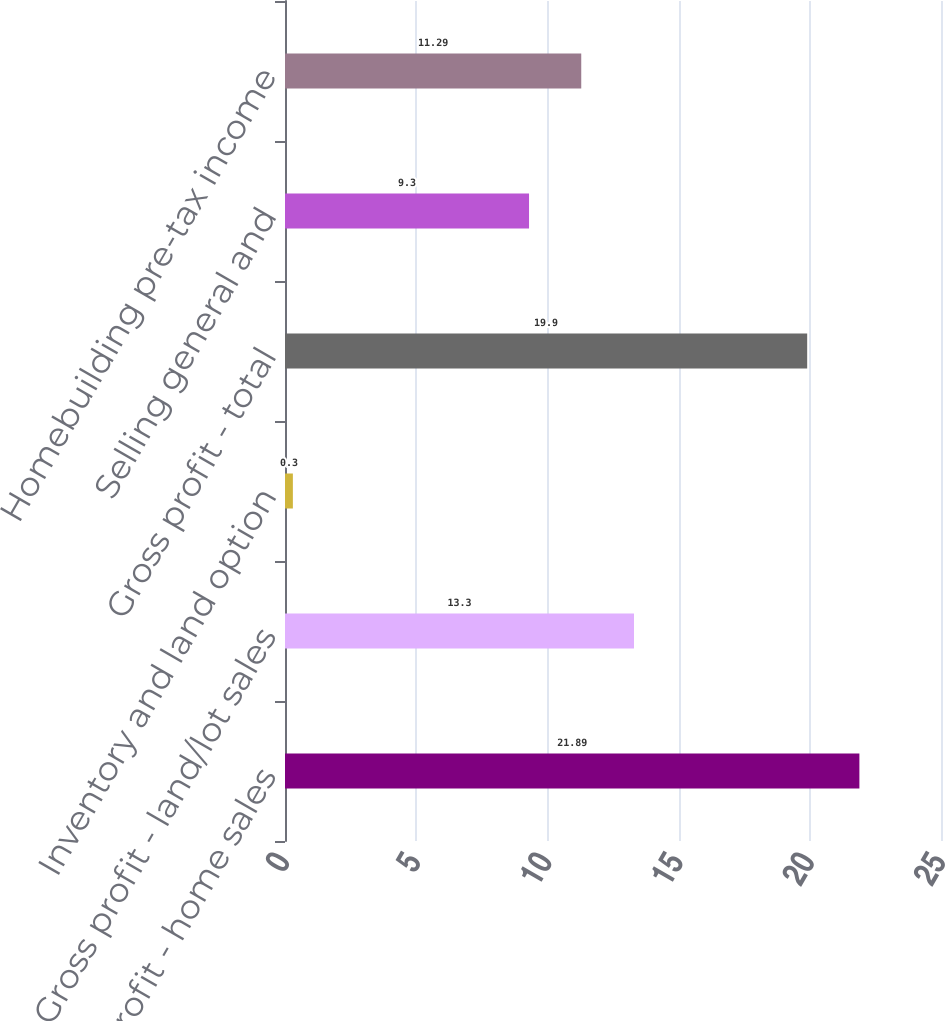Convert chart. <chart><loc_0><loc_0><loc_500><loc_500><bar_chart><fcel>Gross profit - home sales<fcel>Gross profit - land/lot sales<fcel>Inventory and land option<fcel>Gross profit - total<fcel>Selling general and<fcel>Homebuilding pre-tax income<nl><fcel>21.89<fcel>13.3<fcel>0.3<fcel>19.9<fcel>9.3<fcel>11.29<nl></chart> 